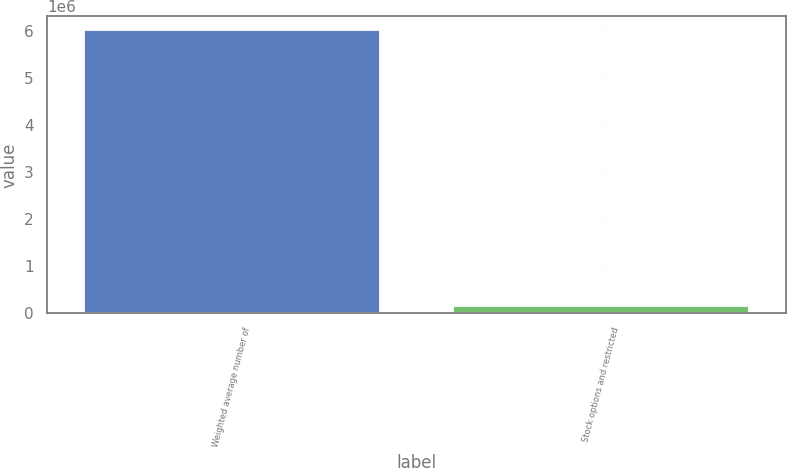Convert chart. <chart><loc_0><loc_0><loc_500><loc_500><bar_chart><fcel>Weighted average number of<fcel>Stock options and restricted<nl><fcel>6.01607e+06<fcel>154658<nl></chart> 